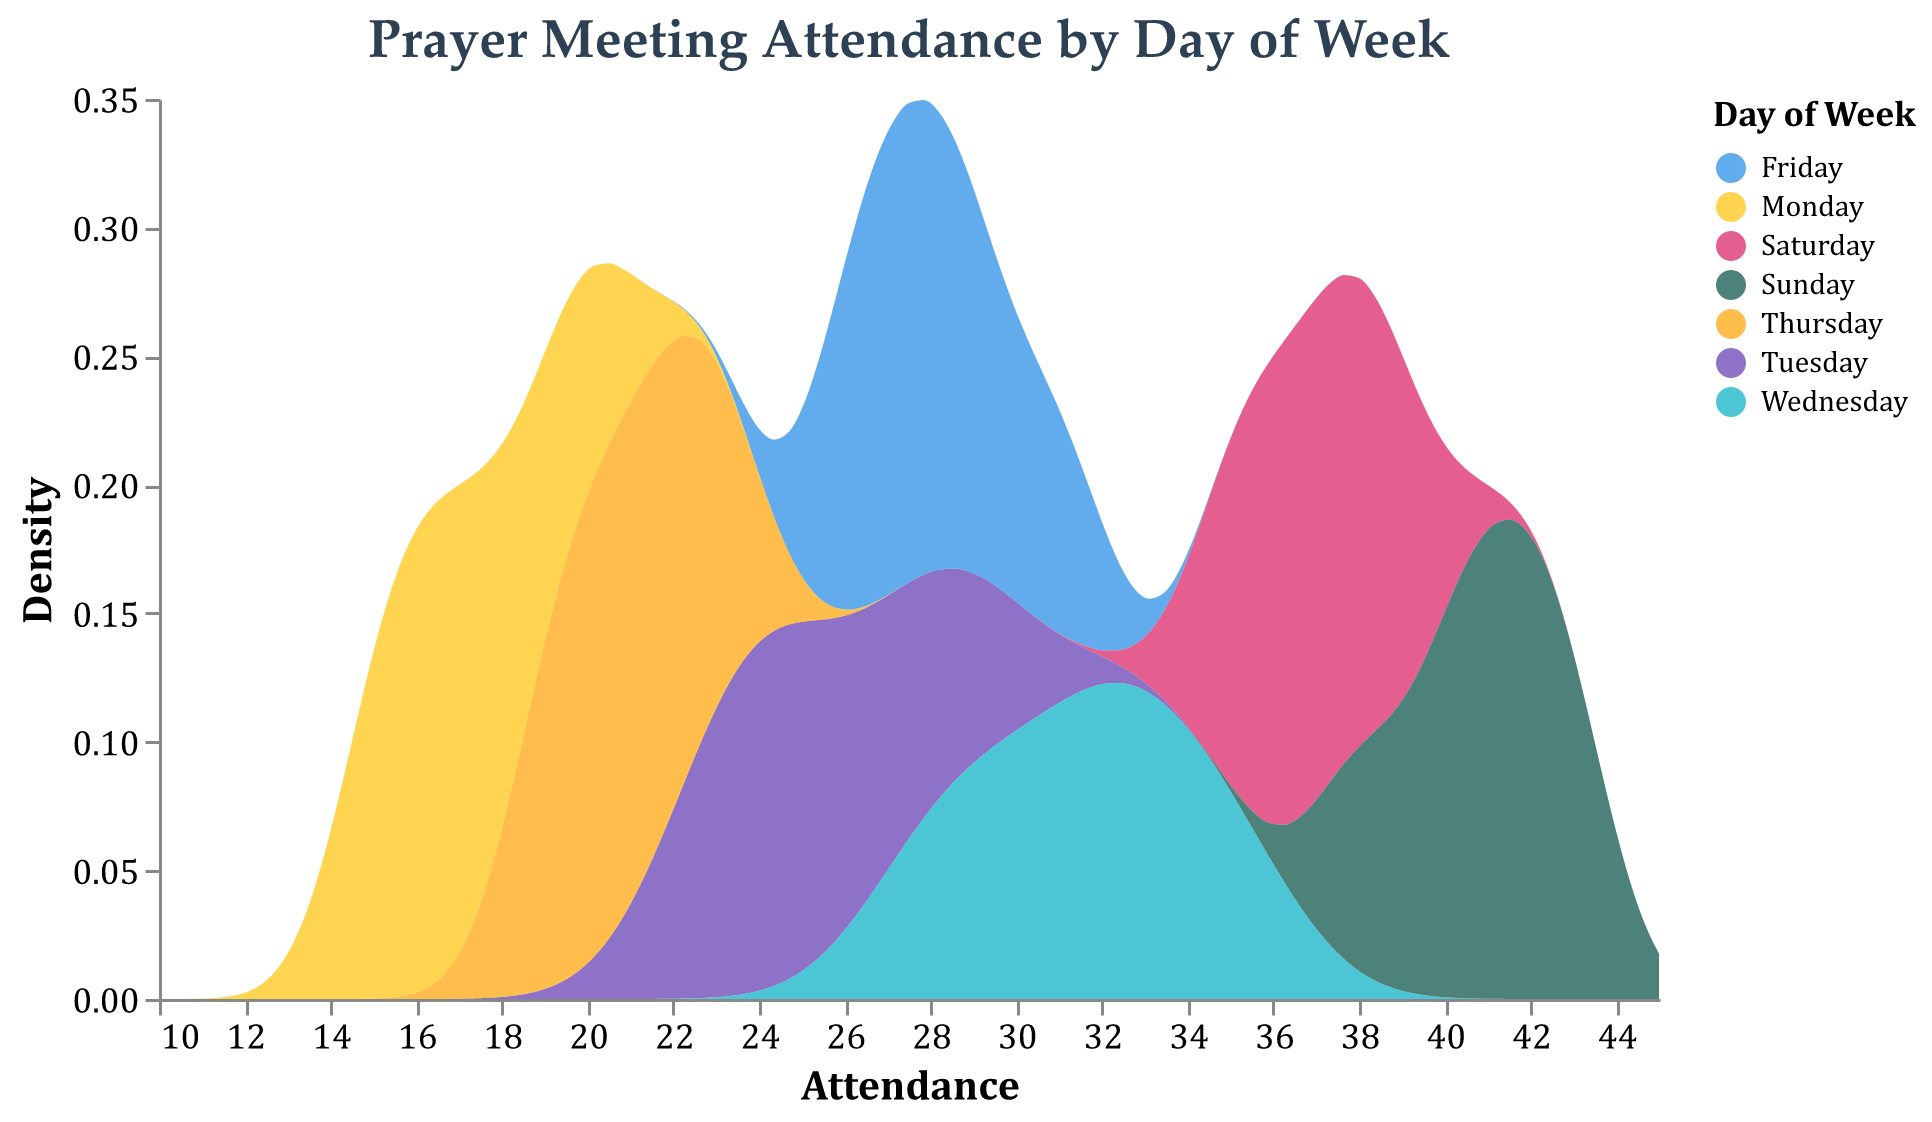What is the title of the plot? The title is displayed at the top of the plot, and it is "Prayer Meeting Attendance by Day of Week."
Answer: Prayer Meeting Attendance by Day of Week Which day has the highest peak attendance density? By examining the plot, the day with the highest peak density (maximum height of the curve) must be identified. The Sunday curve generally has the highest peak, indicating the highest density of attendance on that day.
Answer: Sunday What range of attendance is covered in the plot? The x-axis of the plot indicates the range from the minimum attendance value to the maximum. From the graph, it spans from 10 to 45.
Answer: 10 to 45 How does the attendance on Tuesday compare to Thursday? To compare, look at the peak and overall density curves for Tuesday and Thursday. Generally, Tuesday has a peak attendance density higher than Thursday, indicating Tuesday has better attendance than Thursday.
Answer: Tuesday has higher attendance What is the approximate peak density value for Saturday? To find the peak density value for Saturday, look at the highest point of the Saturday curve on the y-axis. Based on the y-axis values, Saturday's peak density is approximately around 0.05.
Answer: 0.05 On which day is attendance most spread out? By examining each curve's width, the most spread-out density curve indicates variability in attendance. Monday's curve is wider and flatter compared to others, showing a more spread-out attendance range.
Answer: Monday Which days have attendance densities primarily above 20 people? By observing which days' density curves start significantly above the 20-person mark on the x-axis, Sunday, Saturday, Wednesday, and Friday have densities primarily above 20 people most of the time.
Answer: Sunday, Saturday, Wednesday, and Friday What can be inferred about average attendance on Wednesday compared to Monday? By comparing the hump location and spread of the density curves, Wednesday's curve at a higher attendance range indicates a larger average attendance than Monday.
Answer: Higher on Wednesday 